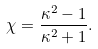Convert formula to latex. <formula><loc_0><loc_0><loc_500><loc_500>\chi = \frac { \kappa ^ { 2 } - 1 } { \kappa ^ { 2 } + 1 } .</formula> 